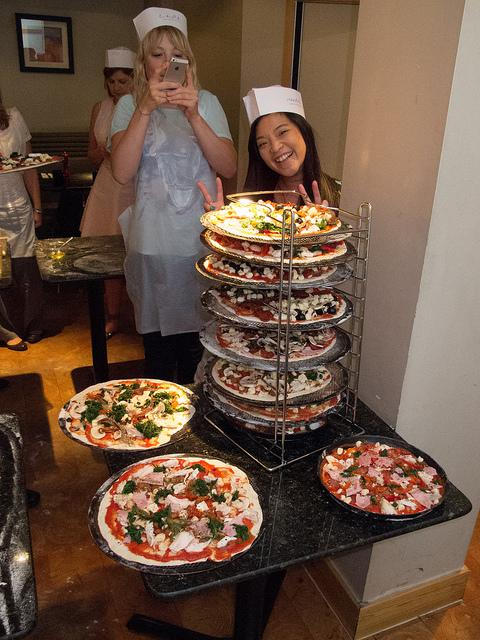What will these ladies next do with the pizzas? Please explain your reasoning. bake. These ladies are baking pizzas. 